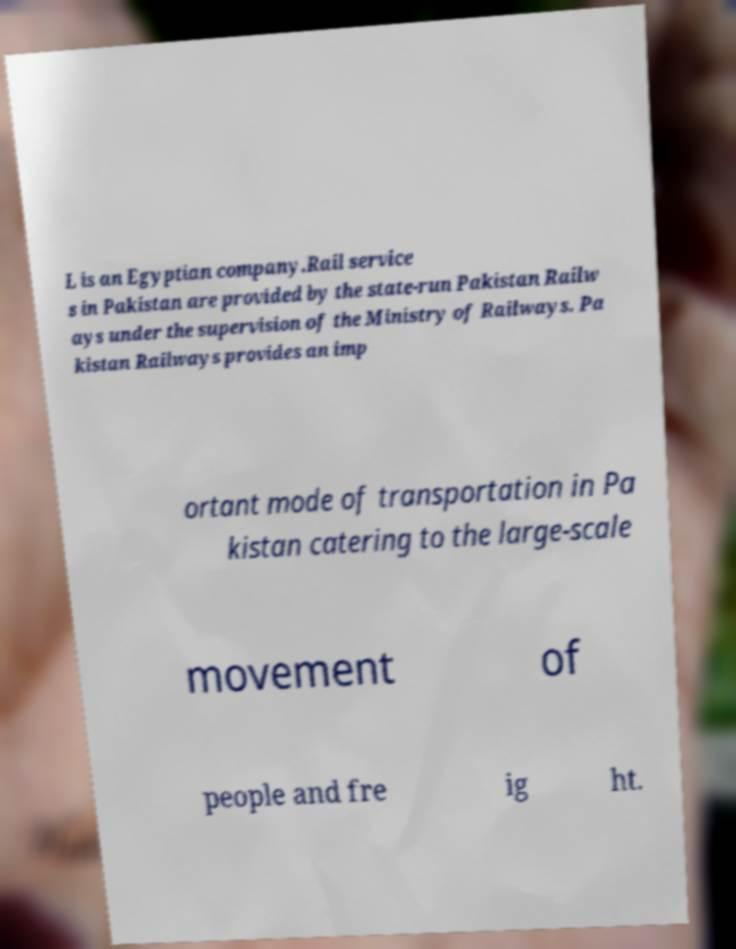There's text embedded in this image that I need extracted. Can you transcribe it verbatim? L is an Egyptian company.Rail service s in Pakistan are provided by the state-run Pakistan Railw ays under the supervision of the Ministry of Railways. Pa kistan Railways provides an imp ortant mode of transportation in Pa kistan catering to the large-scale movement of people and fre ig ht. 